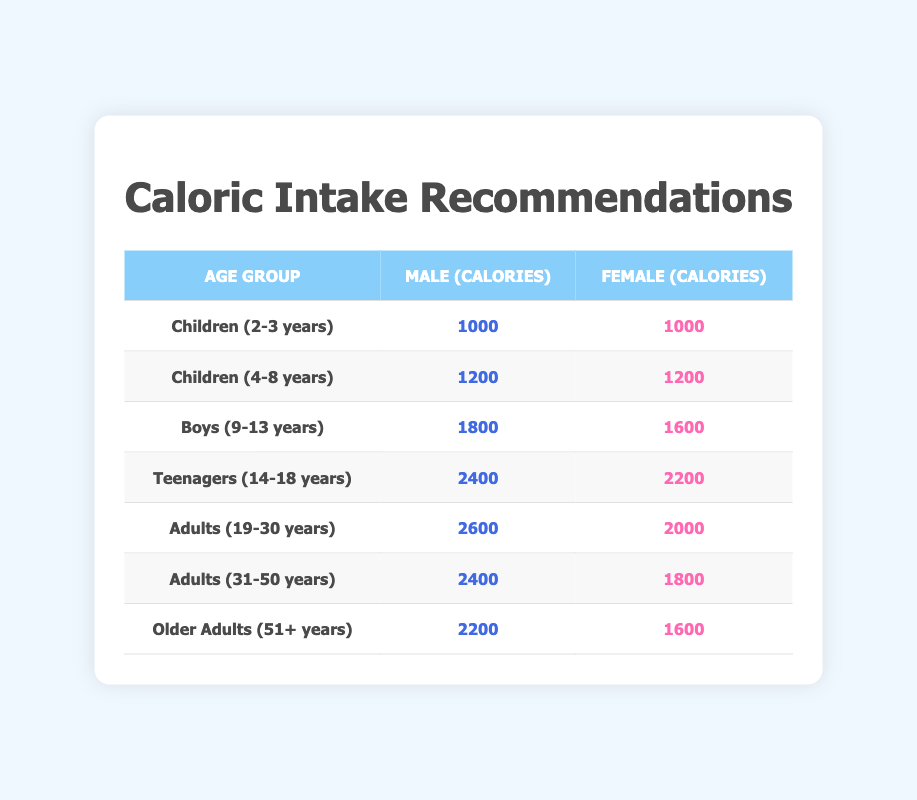What is the daily caloric intake for teenage boys? By looking at the table, the row for "Teenagers (14-18 years)" shows that the daily caloric intake for boys is **2400** calories.
Answer: 2400 What is the difference in daily caloric intake between adult males and females aged 19-30? From the table, the daily caloric intake for adult males (19-30 years) is **2600** calories and for females is **2000** calories. The difference is 2600 - 2000 = 600.
Answer: 600 Is the caloric intake for girls aged 4-8 years the same as for boys in the same age group? The table indicates that both boys and girls aged 4-8 years have a daily caloric intake of **1200** calories. Thus, they are the same.
Answer: Yes What is the average daily caloric intake for all age groups listed for females? To find the average caloric intake for females, sum all the female values: (1000 + 1200 + 1600 + 2200 + 2000 + 1800 + 1600) = 12400. There are 7 age groups, so divide 12400 by 7, which gives approximately 1771.43.
Answer: 1771.43 What is the highest daily caloric intake recommended for adult males? The highest daily caloric intake for adult males is found in the row for "Adults (19-30 years)" with **2600** calories.
Answer: 2600 If a girl is aged 9 years, how many calories should she consume according to the table? For girls aged 9-13 years, the row for "Boys (9-13 years)" shows girls (though data for girls in this row is usually for that age range) should have a daily intake of **1600** calories.
Answer: 1600 What is the total caloric intake for both male and female teenagers combined? The male intake is **2400** and female is **2200** for teenagers (14-18 years). Adding these gives 2400 + 2200 = 4600 calories total.
Answer: 4600 Is the daily caloric recommendation for older adult females higher than that for adult females (19-30 years)? The table shows daily caloric intake for older adult females as **1600** and for adult females as **2000**. Since 1600 is less than 2000, the statement is false.
Answer: No What is the daily caloric intake for children aged 2-3 years? Referring to the table, both males and females aged 2-3 years have a daily caloric intake of **1000** calories.
Answer: 1000 What is the sum of daily caloric intakes for boys aged 9-13 and teenagers aged 14-18? For boys aged 9-13, the intake is **1800** and for teenagers, it's **2400**. Adding these gives 1800 + 2400 = 4200 calories.
Answer: 4200 